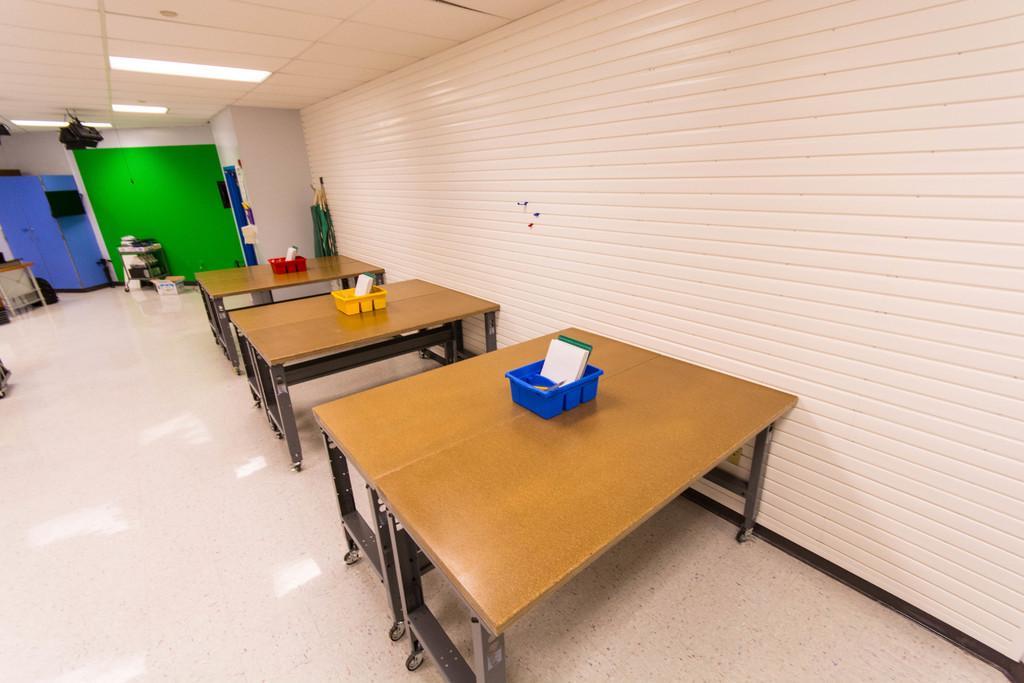How would you summarize this image in a sentence or two? In this image, there are three wooden tables with the baskets on it. This is a kind of a rack. I can see a cardboard box, which is placed on the floor. This is an object, which is hanging. I think these are the boards, which are blue and green in color. I can see few objects, which are at the corners of the room. At the top of the image, I can see the ceiling lights, which are attached to the ceiling. This is the wall. 